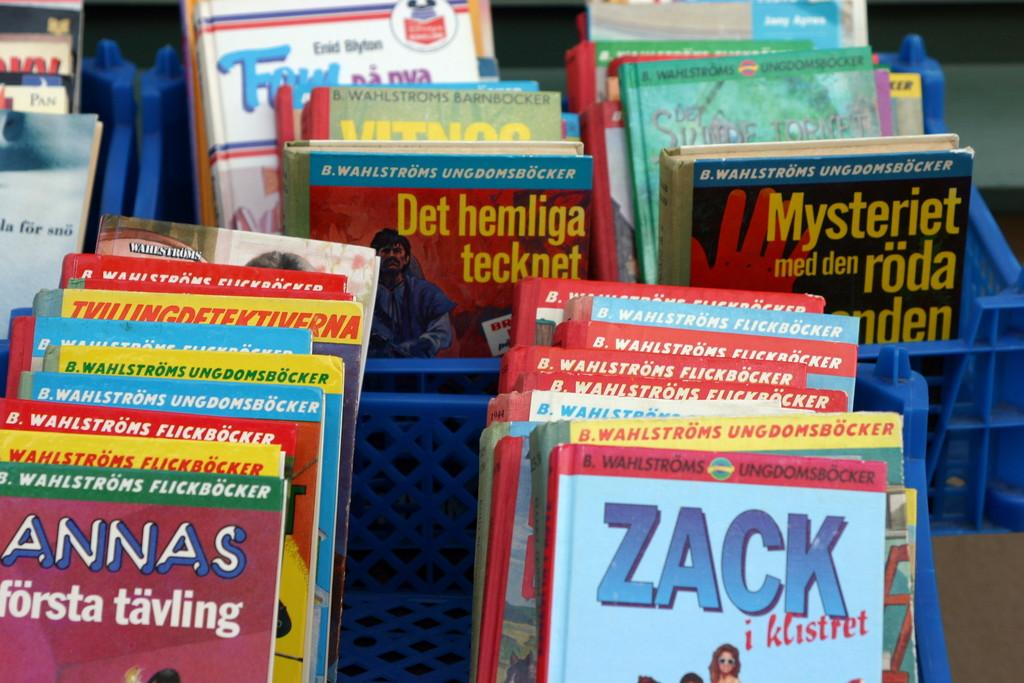<image>
Relay a brief, clear account of the picture shown. Several books in blue boxes which are in a foreign language. 